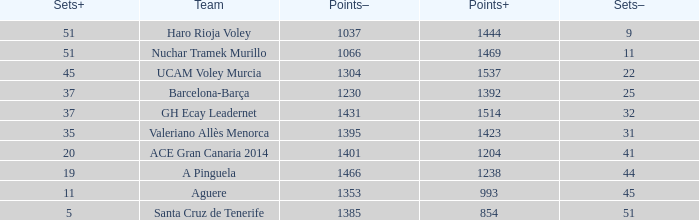What is the total number of Points- when the Sets- is larger than 51? 0.0. 